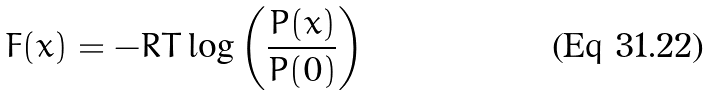<formula> <loc_0><loc_0><loc_500><loc_500>F ( x ) = - R T \log \left ( \frac { P ( x ) } { P ( 0 ) } \right )</formula> 